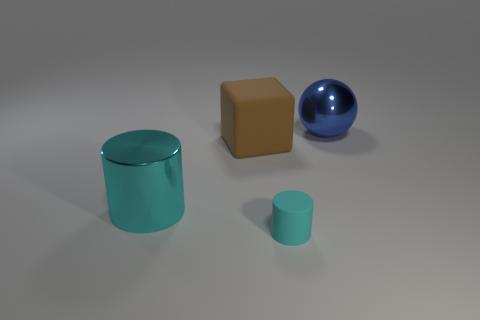The large object to the right of the cyan cylinder in front of the shiny object in front of the blue ball is made of what material?
Ensure brevity in your answer.  Metal. Are there any things of the same size as the brown cube?
Your response must be concise. Yes. What is the shape of the cyan metallic object?
Offer a terse response. Cylinder. What number of cubes are tiny green matte things or big blue shiny things?
Make the answer very short. 0. Are there the same number of rubber blocks that are to the right of the sphere and tiny rubber cylinders behind the brown block?
Provide a short and direct response. Yes. There is a cyan cylinder that is in front of the metallic object to the left of the cyan rubber thing; how many big blue balls are to the left of it?
Provide a short and direct response. 0. Is the color of the big ball the same as the metallic thing that is in front of the large metal sphere?
Your answer should be compact. No. Are there more cylinders that are behind the small cyan matte cylinder than cyan metallic cylinders?
Provide a short and direct response. No. How many objects are either large metal things that are in front of the blue thing or cylinders that are on the right side of the large brown matte cube?
Your answer should be very brief. 2. There is a cyan object that is made of the same material as the brown object; what is its size?
Make the answer very short. Small. 